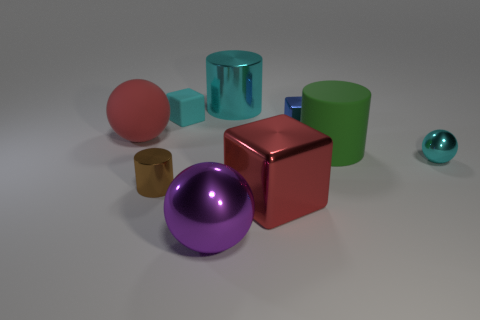What number of things are behind the large shiny block? There are five objects positioned behind the large red shiny cube: a green cylinder, a smaller blue-green transparent cube, a small orange cylinder, a purplish sphere, and a very small teal sphere. 